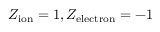<formula> <loc_0><loc_0><loc_500><loc_500>Z _ { i o n } = 1 , Z _ { e l e c t r o n } = - 1</formula> 